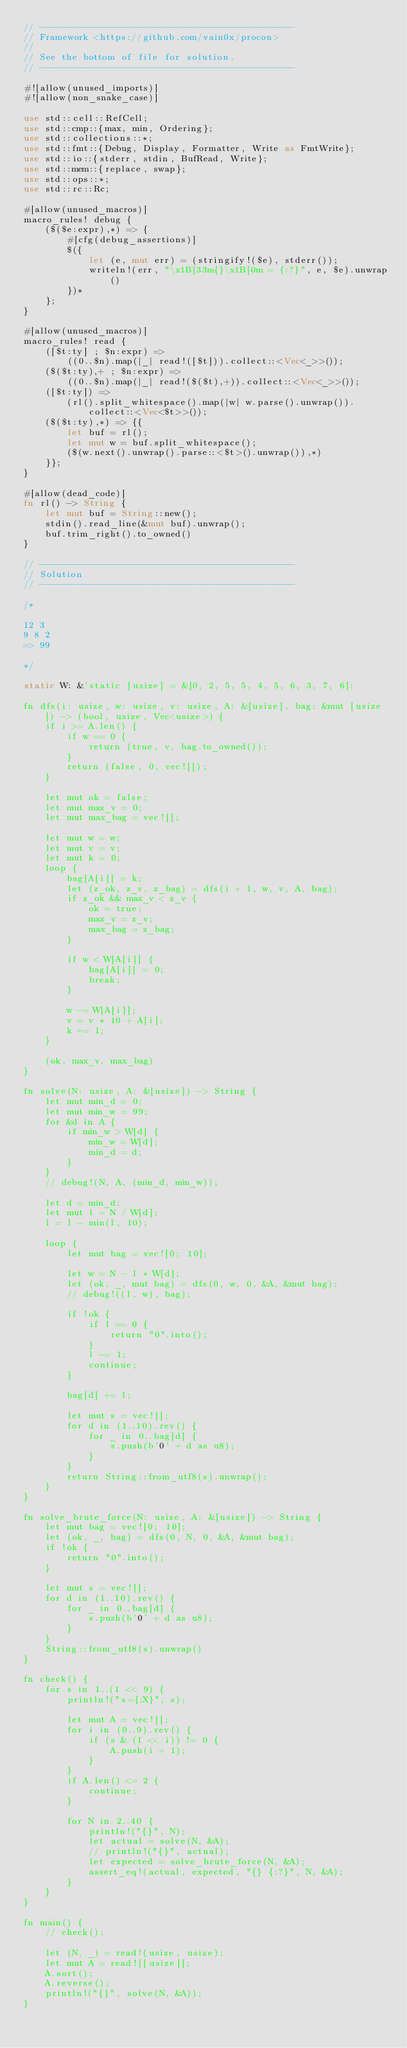<code> <loc_0><loc_0><loc_500><loc_500><_Rust_>// -----------------------------------------------
// Framework <https://github.com/vain0x/procon>
//
// See the bottom of file for solution.
// -----------------------------------------------

#![allow(unused_imports)]
#![allow(non_snake_case)]

use std::cell::RefCell;
use std::cmp::{max, min, Ordering};
use std::collections::*;
use std::fmt::{Debug, Display, Formatter, Write as FmtWrite};
use std::io::{stderr, stdin, BufRead, Write};
use std::mem::{replace, swap};
use std::ops::*;
use std::rc::Rc;

#[allow(unused_macros)]
macro_rules! debug {
    ($($e:expr),*) => {
        #[cfg(debug_assertions)]
        $({
            let (e, mut err) = (stringify!($e), stderr());
            writeln!(err, "\x1B[33m{}\x1B[0m = {:?}", e, $e).unwrap()
        })*
    };
}

#[allow(unused_macros)]
macro_rules! read {
    ([$t:ty] ; $n:expr) =>
        ((0..$n).map(|_| read!([$t])).collect::<Vec<_>>());
    ($($t:ty),+ ; $n:expr) =>
        ((0..$n).map(|_| read!($($t),+)).collect::<Vec<_>>());
    ([$t:ty]) =>
        (rl().split_whitespace().map(|w| w.parse().unwrap()).collect::<Vec<$t>>());
    ($($t:ty),*) => {{
        let buf = rl();
        let mut w = buf.split_whitespace();
        ($(w.next().unwrap().parse::<$t>().unwrap()),*)
    }};
}

#[allow(dead_code)]
fn rl() -> String {
    let mut buf = String::new();
    stdin().read_line(&mut buf).unwrap();
    buf.trim_right().to_owned()
}

// -----------------------------------------------
// Solution
// -----------------------------------------------

/*

12 3
9 8 2
=> 99

*/

static W: &'static [usize] = &[0, 2, 5, 5, 4, 5, 6, 3, 7, 6];

fn dfs(i: usize, w: usize, v: usize, A: &[usize], bag: &mut [usize]) -> (bool, usize, Vec<usize>) {
    if i >= A.len() {
        if w == 0 {
            return (true, v, bag.to_owned());
        }
        return (false, 0, vec![]);
    }

    let mut ok = false;
    let mut max_v = 0;
    let mut max_bag = vec![];

    let mut w = w;
    let mut v = v;
    let mut k = 0;
    loop {
        bag[A[i]] = k;
        let (z_ok, z_v, z_bag) = dfs(i + 1, w, v, A, bag);
        if z_ok && max_v < z_v {
            ok = true;
            max_v = z_v;
            max_bag = z_bag;
        }

        if w < W[A[i]] {
            bag[A[i]] = 0;
            break;
        }

        w -= W[A[i]];
        v = v * 10 + A[i];
        k += 1;
    }

    (ok, max_v, max_bag)
}

fn solve(N: usize, A: &[usize]) -> String {
    let mut min_d = 0;
    let mut min_w = 99;
    for &d in A {
        if min_w > W[d] {
            min_w = W[d];
            min_d = d;
        }
    }
    // debug!(N, A, (min_d, min_w));

    let d = min_d;
    let mut l = N / W[d];
    l = l - min(l, 10);

    loop {
        let mut bag = vec![0; 10];

        let w = N - l * W[d];
        let (ok, _, mut bag) = dfs(0, w, 0, &A, &mut bag);
        // debug!((l, w), bag);

        if !ok {
            if l == 0 {
                return "0".into();
            }
            l -= 1;
            continue;
        }

        bag[d] += l;

        let mut s = vec![];
        for d in (1..10).rev() {
            for _ in 0..bag[d] {
                s.push(b'0' + d as u8);
            }
        }
        return String::from_utf8(s).unwrap();
    }
}

fn solve_brute_force(N: usize, A: &[usize]) -> String {
    let mut bag = vec![0; 10];
    let (ok, _, bag) = dfs(0, N, 0, &A, &mut bag);
    if !ok {
        return "0".into();
    }

    let mut s = vec![];
    for d in (1..10).rev() {
        for _ in 0..bag[d] {
            s.push(b'0' + d as u8);
        }
    }
    String::from_utf8(s).unwrap()
}

fn check() {
    for s in 1..(1 << 9) {
        println!("s={:X}", s);

        let mut A = vec![];
        for i in (0..9).rev() {
            if (s & (1 << i)) != 0 {
                A.push(i + 1);
            }
        }
        if A.len() <= 2 {
            continue;
        }

        for N in 2..40 {
            println!("{}", N);
            let actual = solve(N, &A);
            // println!("{}", actual);
            let expected = solve_brute_force(N, &A);
            assert_eq!(actual, expected, "{} {:?}", N, &A);
        }
    }
}

fn main() {
    // check();

    let (N, _) = read!(usize, usize);
    let mut A = read![[usize]];
    A.sort();
    A.reverse();
    println!("{}", solve(N, &A));
}
</code> 